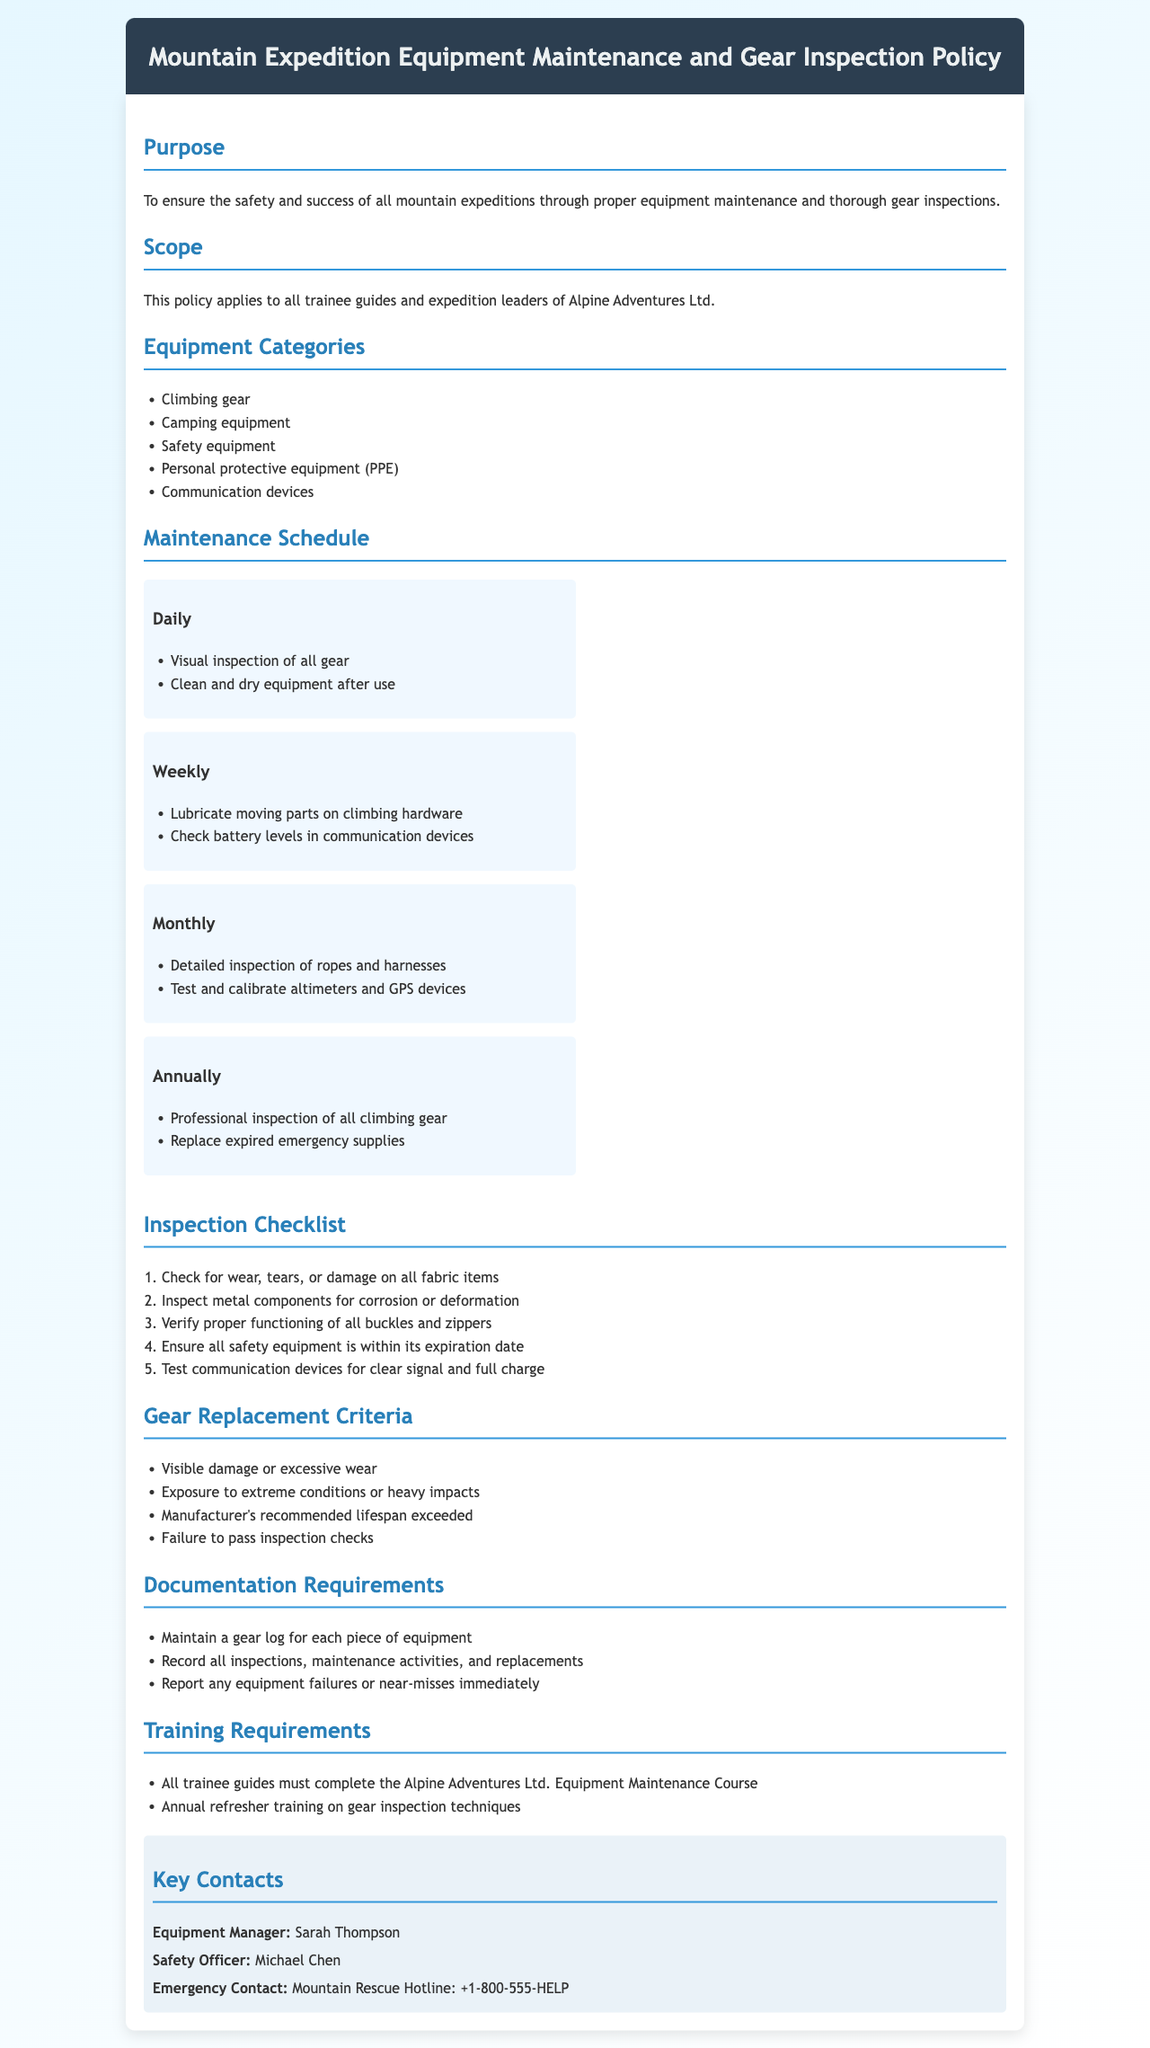What is the purpose of the policy? The policy is to ensure the safety and success of all mountain expeditions through proper equipment maintenance and thorough gear inspections.
Answer: To ensure the safety and success of all mountain expeditions through proper equipment maintenance and thorough gear inspections Who is the Equipment Manager? The document specifies a contact person for equipment management.
Answer: Sarah Thompson What type of equipment must be visually inspected daily? This refers to the gear that requires a daily check as mentioned in the document.
Answer: All gear How often should a detailed inspection of ropes and harnesses be conducted? The document outlines a schedule for inspections, including the frequency of detailed inspections.
Answer: Monthly What is one criterion for gear replacement? The document provides several criteria for when gear should be replaced.
Answer: Visible damage or excessive wear What training must all trainee guides complete? This question references the required training for trainee guides as per the policy document.
Answer: Alpine Adventures Ltd. Equipment Maintenance Course What is the contact number for emergency assistance? The document lists key contacts, including emergency contacts for expeditions.
Answer: +1-800-555-HELP How frequently should moving parts on climbing hardware be lubricated? The maintenance schedule indicates how often this task needs to be performed.
Answer: Weekly What should be documented for each piece of equipment? The document explains documentation requirements related to gear maintenance and inspection.
Answer: Maintain a gear log for each piece of equipment 